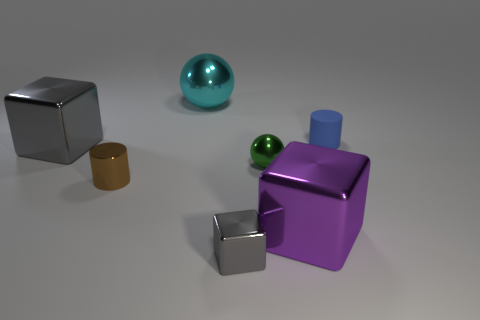Add 1 cyan shiny objects. How many objects exist? 8 Subtract all cylinders. How many objects are left? 5 Subtract all small gray cubes. Subtract all small red metal objects. How many objects are left? 6 Add 2 small matte things. How many small matte things are left? 3 Add 3 big spheres. How many big spheres exist? 4 Subtract 0 brown balls. How many objects are left? 7 